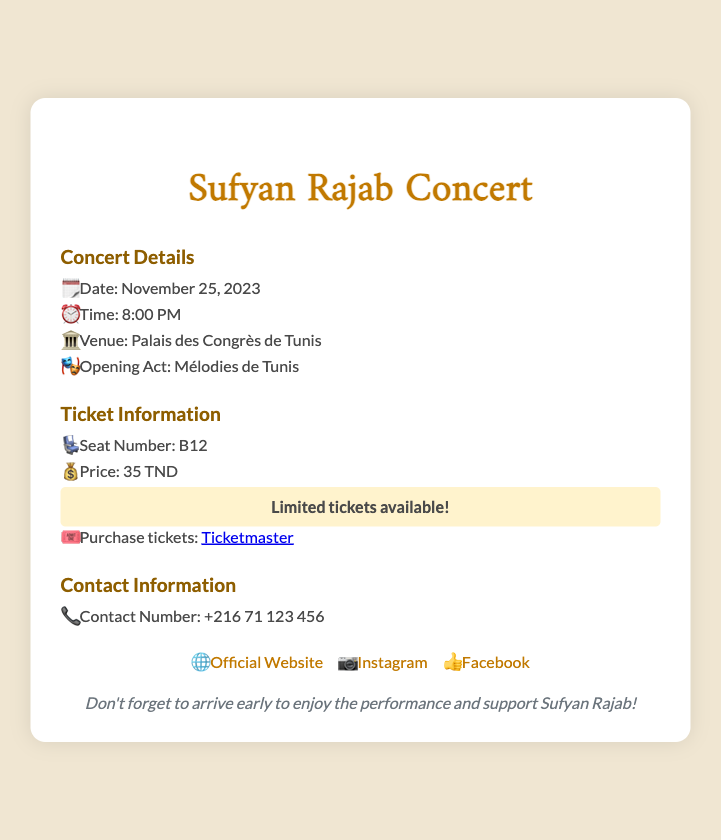What is the date of the concert? The concert date is explicitly mentioned in the document as November 25, 2023.
Answer: November 25, 2023 What is the seat number listed on the ticket? The ticket information section provides the seat number as B12.
Answer: B12 What is the venue for the concert? The document specifies the venue where the concert will take place as Palais des Congrès de Tunis.
Answer: Palais des Congrès de Tunis How much does the ticket cost? The price of the ticket is listed in the ticket information section as 35 TND.
Answer: 35 TND What time does the concert start? The starting time of the concert is given as 8:00 PM in the concert details section.
Answer: 8:00 PM What is the opening act for the concert? The document indicates that the opening act will be Mélodies de Tunis.
Answer: Mélodies de Tunis Where can I purchase the tickets? The document provides a link to purchase tickets at Ticketmaster.
Answer: Ticketmaster What should attendees remember to do before the concert? There is a reminder indicating that attendees should arrive early to enjoy the performance.
Answer: Arrive early 